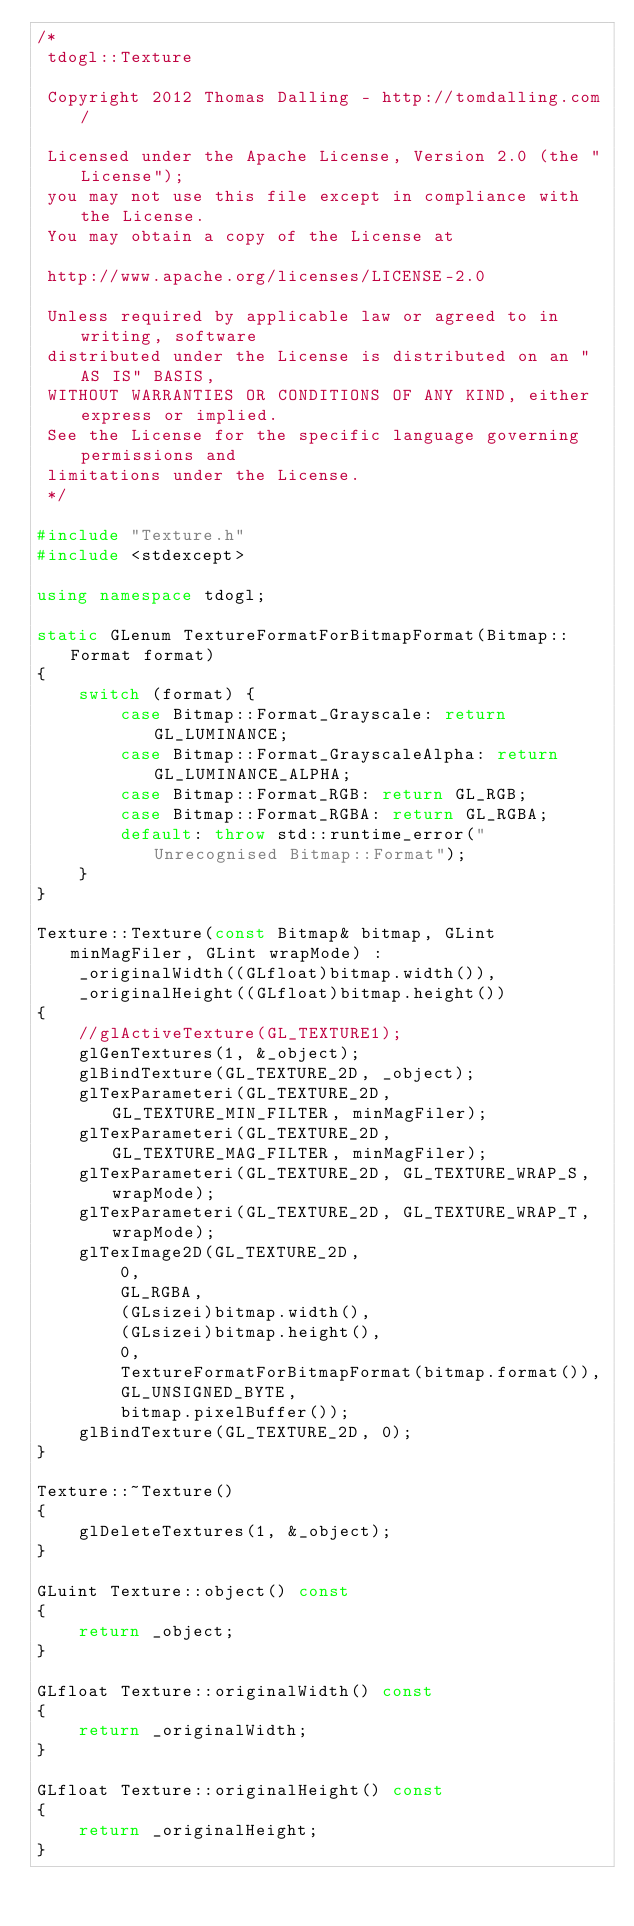<code> <loc_0><loc_0><loc_500><loc_500><_C++_>/*
 tdogl::Texture
 
 Copyright 2012 Thomas Dalling - http://tomdalling.com/
 
 Licensed under the Apache License, Version 2.0 (the "License");
 you may not use this file except in compliance with the License.
 You may obtain a copy of the License at
 
 http://www.apache.org/licenses/LICENSE-2.0
 
 Unless required by applicable law or agreed to in writing, software
 distributed under the License is distributed on an "AS IS" BASIS,
 WITHOUT WARRANTIES OR CONDITIONS OF ANY KIND, either express or implied.
 See the License for the specific language governing permissions and
 limitations under the License.
 */

#include "Texture.h"
#include <stdexcept>

using namespace tdogl;

static GLenum TextureFormatForBitmapFormat(Bitmap::Format format)
{
    switch (format) {
        case Bitmap::Format_Grayscale: return GL_LUMINANCE;
        case Bitmap::Format_GrayscaleAlpha: return GL_LUMINANCE_ALPHA;
        case Bitmap::Format_RGB: return GL_RGB;
        case Bitmap::Format_RGBA: return GL_RGBA;
        default: throw std::runtime_error("Unrecognised Bitmap::Format");
    }
}

Texture::Texture(const Bitmap& bitmap, GLint minMagFiler, GLint wrapMode) :
    _originalWidth((GLfloat)bitmap.width()),
    _originalHeight((GLfloat)bitmap.height())
{
	//glActiveTexture(GL_TEXTURE1);
    glGenTextures(1, &_object);
    glBindTexture(GL_TEXTURE_2D, _object);
    glTexParameteri(GL_TEXTURE_2D, GL_TEXTURE_MIN_FILTER, minMagFiler);
    glTexParameteri(GL_TEXTURE_2D, GL_TEXTURE_MAG_FILTER, minMagFiler);
    glTexParameteri(GL_TEXTURE_2D, GL_TEXTURE_WRAP_S, wrapMode);
    glTexParameteri(GL_TEXTURE_2D, GL_TEXTURE_WRAP_T, wrapMode);
	glTexImage2D(GL_TEXTURE_2D,
		0,
		GL_RGBA,
		(GLsizei)bitmap.width(),
		(GLsizei)bitmap.height(),
		0,
		TextureFormatForBitmapFormat(bitmap.format()),
		GL_UNSIGNED_BYTE,
		bitmap.pixelBuffer());
    glBindTexture(GL_TEXTURE_2D, 0);
}

Texture::~Texture()
{
    glDeleteTextures(1, &_object);
}

GLuint Texture::object() const
{
    return _object;
}

GLfloat Texture::originalWidth() const
{
    return _originalWidth;
}

GLfloat Texture::originalHeight() const
{
    return _originalHeight;
}
</code> 